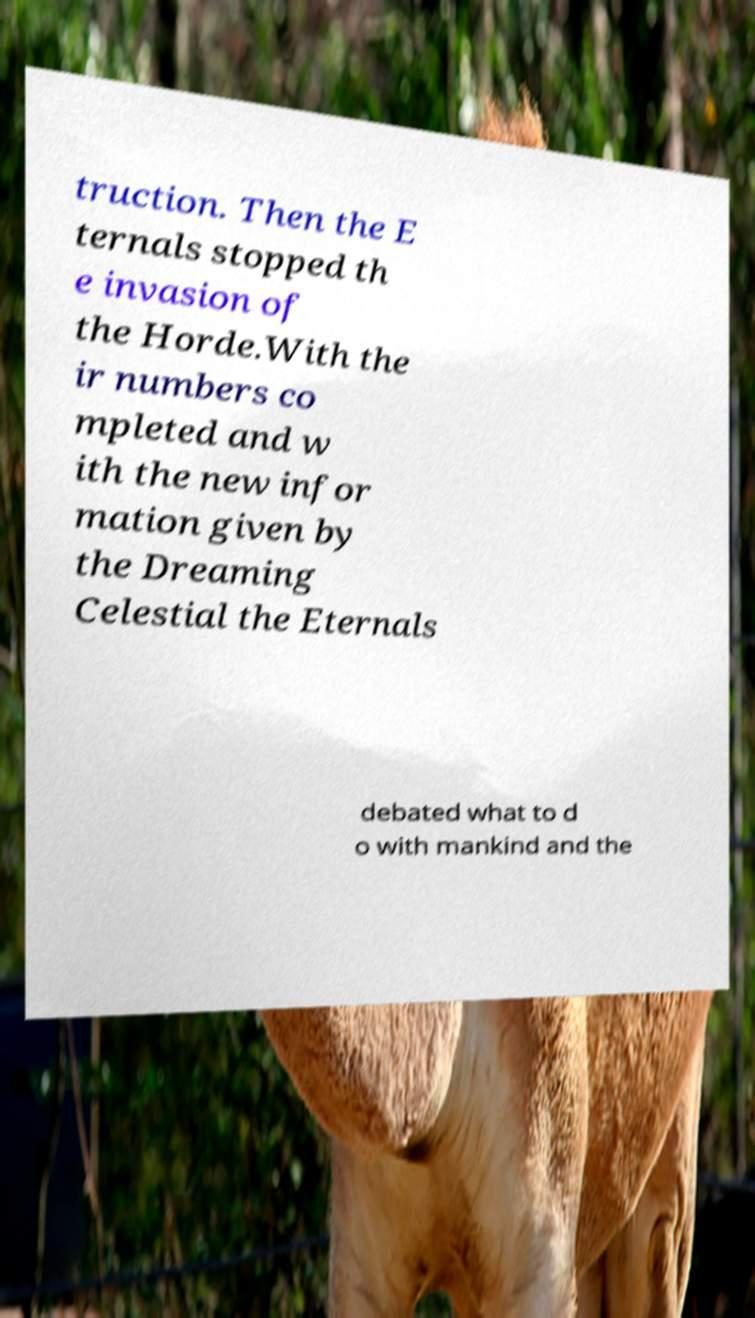What messages or text are displayed in this image? I need them in a readable, typed format. truction. Then the E ternals stopped th e invasion of the Horde.With the ir numbers co mpleted and w ith the new infor mation given by the Dreaming Celestial the Eternals debated what to d o with mankind and the 